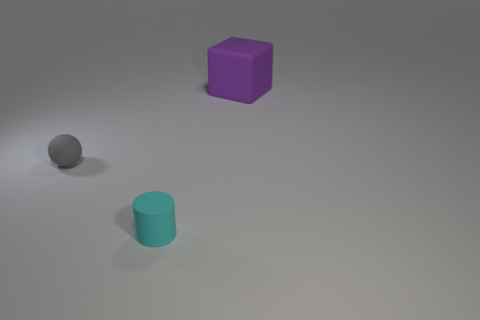What number of other things are there of the same material as the purple thing
Make the answer very short. 2. Is the number of cyan rubber objects that are to the left of the purple cube the same as the number of small cyan rubber spheres?
Provide a short and direct response. No. Does the cylinder have the same size as the thing on the right side of the matte cylinder?
Offer a terse response. No. There is a rubber thing behind the sphere; what is its shape?
Your response must be concise. Cube. Is there anything else that has the same shape as the big thing?
Make the answer very short. No. Is there a thing?
Make the answer very short. Yes. Do the ball behind the cyan thing and the matte object that is right of the cyan matte cylinder have the same size?
Ensure brevity in your answer.  No. What material is the object that is both in front of the purple object and to the right of the gray sphere?
Your answer should be very brief. Rubber. There is a rubber cylinder; how many small gray rubber balls are right of it?
Provide a succinct answer. 0. Are there any other things that are the same size as the cylinder?
Ensure brevity in your answer.  Yes. 